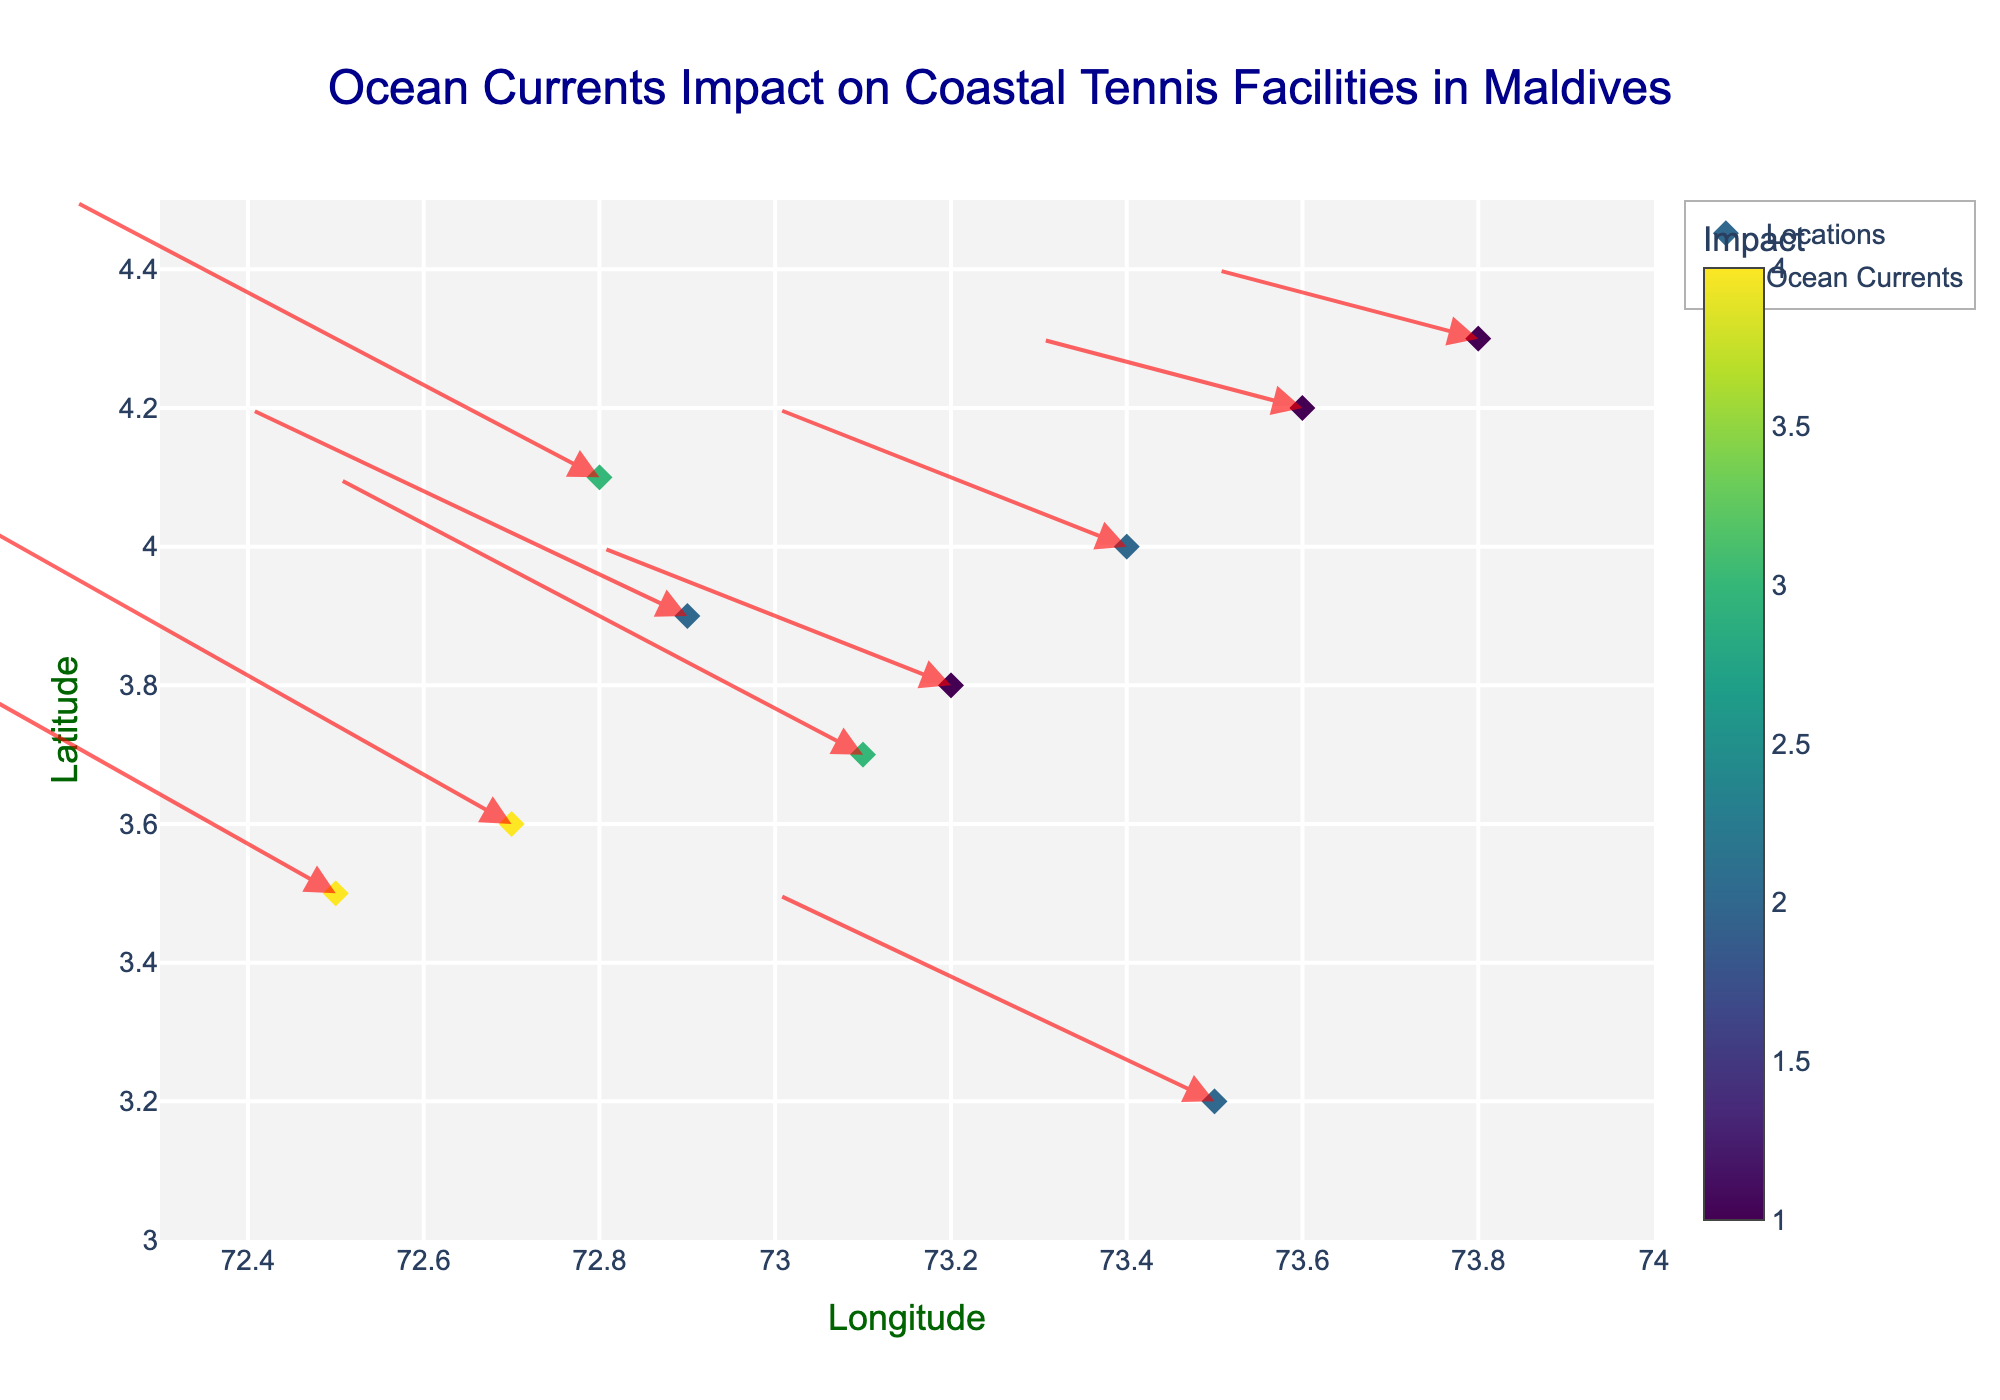What's the title of the plot? The title of the plot is usually located at the top center and provides a brief summary of what the plot represents. In this case, it says "Ocean Currents Impact on Coastal Tennis Facilities in Maldives".
Answer: Ocean Currents Impact on Coastal Tennis Facilities in Maldives What do the colors of the markers represent? The color of the markers is indicated by the colorbar on the right side. It shows a gradient scale with values, which represents the "impact" of ocean currents on the coastal tennis facilities.
Answer: Impact How many data points are there in the plot? By counting the markers (diamond shapes) present in the plot, each representing a pair of (x, y) coordinates, you can determine the number of data points. There are 10 markers in total.
Answer: 10 What range of longitude is covered in the plot? The x-axis represents longitude, with labeled tick marks indicating the minimum and maximum values. In this case, the range is approximately from 72.5 to 73.8
Answer: 72.5 to 73.8 What's the direction of the ocean current at the point (73.5, 3.2)? The direction of the current is indicated by the arrow's direction which originates from the point (73.5, 3.2). By observing, the arrow points towards a lower x and slightly higher y, indicating westward with a slight northward direction.
Answer: West-Northwest Which location has the highest impact value and what is that value? By observing the color intensity and checking the color scale, the location with the most intense color corresponds to the highest impact value. The highest impact value is 4 at points (72.5, 3.5) and (72.7, 3.6).
Answer: 4 What are the u and v components of the current at (72.8, 4.1)? The u and v components are the horizontal and vertical arrow increments provided in the dataset. At (72.8, 4.1), the u component is -0.6 and the v component is 0.4.
Answer: -0.6, 0.4 How do the directions of ocean currents vary between locations (72.5, 3.5) and (73.2, 3.8)? By comparing the directions of the arrows from these points, you observe that at (72.5, 3.5), the arrow points strongly westward and slightly northward while at (73.2, 3.8), the arrow points moderately westward and slightly northward. Both have a westward direction, but (72.5, 3.5) has a stronger component.
Answer: (72.5, 3.5) has a stronger westward current What is the average latitude of the data points? To find the average latitude, sum all the latitude values and divide by the number of points. The latitudes are: 3.2, 4.1, 3.8, 3.5, 4.3, 3.9, 4.0, 3.7, 4.2, and 3.6. Sum is 38.3. Dividing by 10 gives us 3.83.
Answer: 3.83 